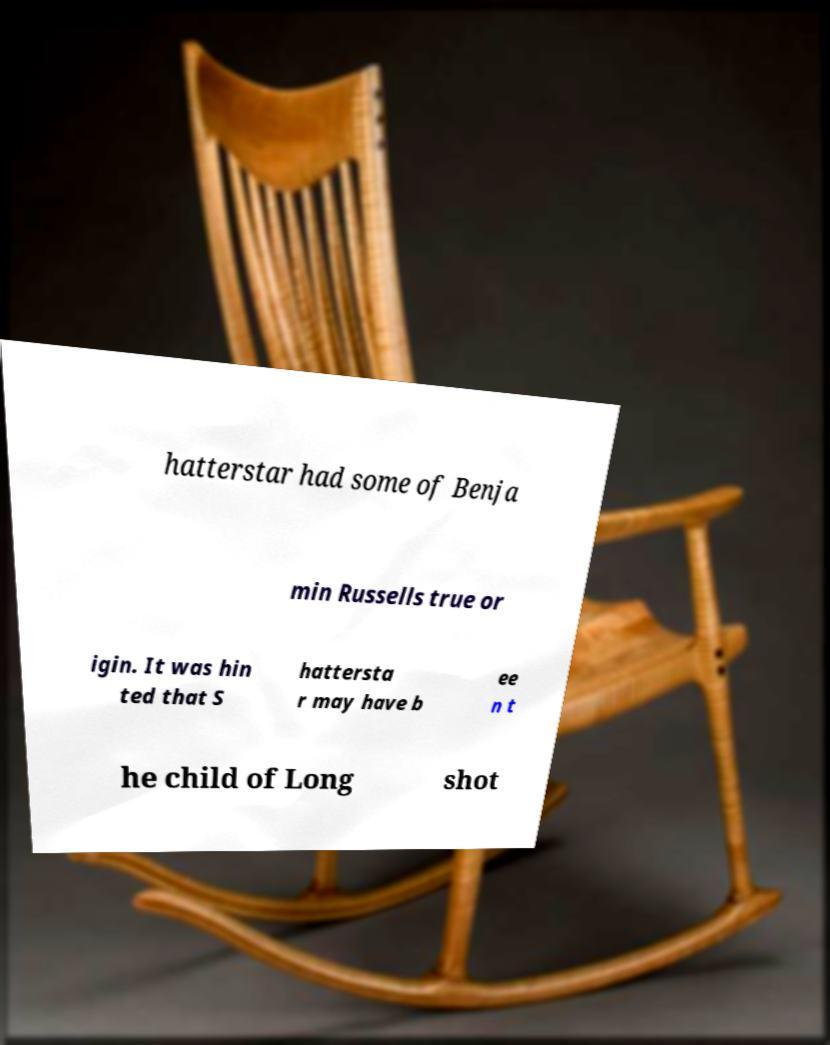Can you read and provide the text displayed in the image?This photo seems to have some interesting text. Can you extract and type it out for me? hatterstar had some of Benja min Russells true or igin. It was hin ted that S hattersta r may have b ee n t he child of Long shot 